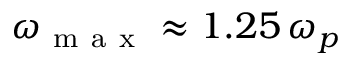<formula> <loc_0><loc_0><loc_500><loc_500>\omega _ { m a x } \approx 1 . 2 5 \, \omega _ { p }</formula> 